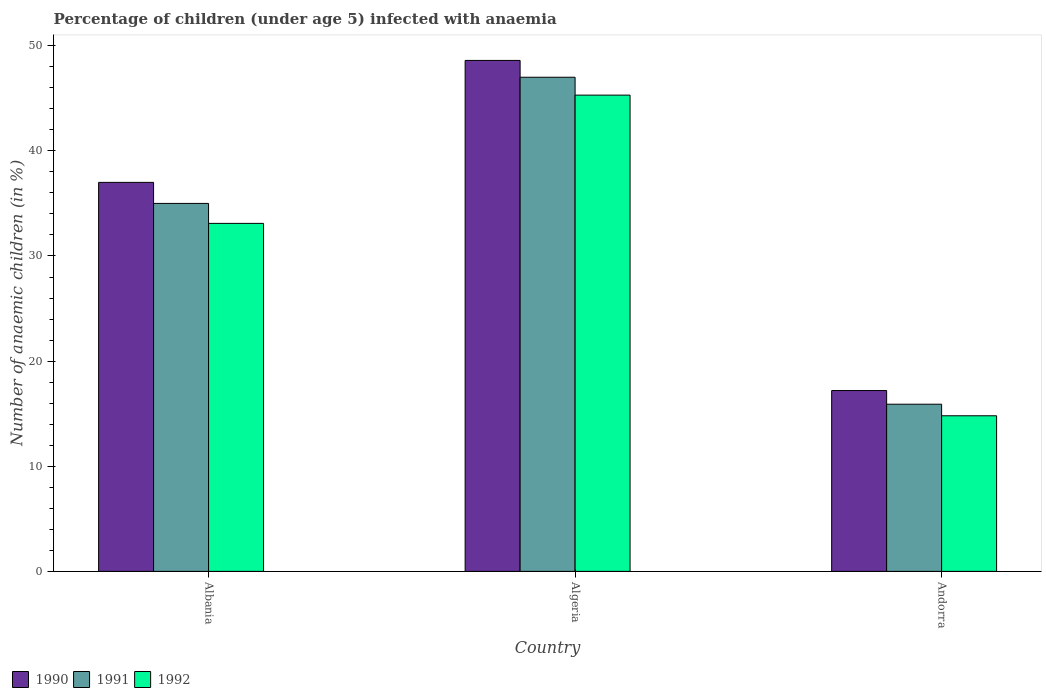Are the number of bars per tick equal to the number of legend labels?
Keep it short and to the point. Yes. How many bars are there on the 2nd tick from the left?
Offer a very short reply. 3. What is the label of the 3rd group of bars from the left?
Your response must be concise. Andorra. What is the percentage of children infected with anaemia in in 1992 in Andorra?
Offer a terse response. 14.8. Across all countries, what is the minimum percentage of children infected with anaemia in in 1992?
Give a very brief answer. 14.8. In which country was the percentage of children infected with anaemia in in 1991 maximum?
Ensure brevity in your answer.  Algeria. In which country was the percentage of children infected with anaemia in in 1990 minimum?
Your answer should be compact. Andorra. What is the total percentage of children infected with anaemia in in 1991 in the graph?
Make the answer very short. 97.9. What is the difference between the percentage of children infected with anaemia in in 1992 in Algeria and that in Andorra?
Provide a short and direct response. 30.5. What is the difference between the percentage of children infected with anaemia in in 1991 in Algeria and the percentage of children infected with anaemia in in 1992 in Albania?
Provide a short and direct response. 13.9. What is the average percentage of children infected with anaemia in in 1991 per country?
Your answer should be very brief. 32.63. What is the difference between the percentage of children infected with anaemia in of/in 1990 and percentage of children infected with anaemia in of/in 1991 in Andorra?
Your answer should be compact. 1.3. In how many countries, is the percentage of children infected with anaemia in in 1990 greater than 10 %?
Your answer should be very brief. 3. What is the ratio of the percentage of children infected with anaemia in in 1991 in Algeria to that in Andorra?
Offer a terse response. 2.96. Is the difference between the percentage of children infected with anaemia in in 1990 in Algeria and Andorra greater than the difference between the percentage of children infected with anaemia in in 1991 in Algeria and Andorra?
Ensure brevity in your answer.  Yes. What is the difference between the highest and the second highest percentage of children infected with anaemia in in 1991?
Keep it short and to the point. 19.1. What is the difference between the highest and the lowest percentage of children infected with anaemia in in 1990?
Keep it short and to the point. 31.4. In how many countries, is the percentage of children infected with anaemia in in 1992 greater than the average percentage of children infected with anaemia in in 1992 taken over all countries?
Provide a succinct answer. 2. Is the sum of the percentage of children infected with anaemia in in 1990 in Albania and Algeria greater than the maximum percentage of children infected with anaemia in in 1992 across all countries?
Ensure brevity in your answer.  Yes. What does the 3rd bar from the left in Albania represents?
Offer a terse response. 1992. How many bars are there?
Make the answer very short. 9. Are all the bars in the graph horizontal?
Your answer should be very brief. No. What is the difference between two consecutive major ticks on the Y-axis?
Make the answer very short. 10. Are the values on the major ticks of Y-axis written in scientific E-notation?
Give a very brief answer. No. Does the graph contain any zero values?
Provide a succinct answer. No. What is the title of the graph?
Provide a short and direct response. Percentage of children (under age 5) infected with anaemia. Does "1974" appear as one of the legend labels in the graph?
Your answer should be very brief. No. What is the label or title of the Y-axis?
Ensure brevity in your answer.  Number of anaemic children (in %). What is the Number of anaemic children (in %) in 1991 in Albania?
Your answer should be very brief. 35. What is the Number of anaemic children (in %) of 1992 in Albania?
Your answer should be compact. 33.1. What is the Number of anaemic children (in %) in 1990 in Algeria?
Your answer should be compact. 48.6. What is the Number of anaemic children (in %) in 1991 in Algeria?
Your answer should be very brief. 47. What is the Number of anaemic children (in %) of 1992 in Algeria?
Provide a succinct answer. 45.3. What is the Number of anaemic children (in %) of 1991 in Andorra?
Your response must be concise. 15.9. What is the Number of anaemic children (in %) in 1992 in Andorra?
Ensure brevity in your answer.  14.8. Across all countries, what is the maximum Number of anaemic children (in %) in 1990?
Give a very brief answer. 48.6. Across all countries, what is the maximum Number of anaemic children (in %) of 1992?
Your response must be concise. 45.3. Across all countries, what is the minimum Number of anaemic children (in %) in 1990?
Give a very brief answer. 17.2. What is the total Number of anaemic children (in %) of 1990 in the graph?
Your answer should be compact. 102.8. What is the total Number of anaemic children (in %) in 1991 in the graph?
Your answer should be very brief. 97.9. What is the total Number of anaemic children (in %) of 1992 in the graph?
Make the answer very short. 93.2. What is the difference between the Number of anaemic children (in %) in 1992 in Albania and that in Algeria?
Give a very brief answer. -12.2. What is the difference between the Number of anaemic children (in %) of 1990 in Albania and that in Andorra?
Make the answer very short. 19.8. What is the difference between the Number of anaemic children (in %) in 1990 in Algeria and that in Andorra?
Give a very brief answer. 31.4. What is the difference between the Number of anaemic children (in %) in 1991 in Algeria and that in Andorra?
Offer a terse response. 31.1. What is the difference between the Number of anaemic children (in %) of 1992 in Algeria and that in Andorra?
Offer a terse response. 30.5. What is the difference between the Number of anaemic children (in %) in 1990 in Albania and the Number of anaemic children (in %) in 1991 in Algeria?
Keep it short and to the point. -10. What is the difference between the Number of anaemic children (in %) in 1990 in Albania and the Number of anaemic children (in %) in 1992 in Algeria?
Ensure brevity in your answer.  -8.3. What is the difference between the Number of anaemic children (in %) in 1990 in Albania and the Number of anaemic children (in %) in 1991 in Andorra?
Your response must be concise. 21.1. What is the difference between the Number of anaemic children (in %) of 1991 in Albania and the Number of anaemic children (in %) of 1992 in Andorra?
Your response must be concise. 20.2. What is the difference between the Number of anaemic children (in %) of 1990 in Algeria and the Number of anaemic children (in %) of 1991 in Andorra?
Your response must be concise. 32.7. What is the difference between the Number of anaemic children (in %) in 1990 in Algeria and the Number of anaemic children (in %) in 1992 in Andorra?
Offer a terse response. 33.8. What is the difference between the Number of anaemic children (in %) in 1991 in Algeria and the Number of anaemic children (in %) in 1992 in Andorra?
Make the answer very short. 32.2. What is the average Number of anaemic children (in %) in 1990 per country?
Your answer should be compact. 34.27. What is the average Number of anaemic children (in %) of 1991 per country?
Your answer should be very brief. 32.63. What is the average Number of anaemic children (in %) in 1992 per country?
Offer a very short reply. 31.07. What is the difference between the Number of anaemic children (in %) of 1990 and Number of anaemic children (in %) of 1991 in Albania?
Give a very brief answer. 2. What is the difference between the Number of anaemic children (in %) in 1990 and Number of anaemic children (in %) in 1992 in Albania?
Keep it short and to the point. 3.9. What is the difference between the Number of anaemic children (in %) in 1991 and Number of anaemic children (in %) in 1992 in Albania?
Your answer should be compact. 1.9. What is the difference between the Number of anaemic children (in %) of 1990 and Number of anaemic children (in %) of 1991 in Andorra?
Make the answer very short. 1.3. What is the ratio of the Number of anaemic children (in %) of 1990 in Albania to that in Algeria?
Give a very brief answer. 0.76. What is the ratio of the Number of anaemic children (in %) of 1991 in Albania to that in Algeria?
Give a very brief answer. 0.74. What is the ratio of the Number of anaemic children (in %) in 1992 in Albania to that in Algeria?
Your response must be concise. 0.73. What is the ratio of the Number of anaemic children (in %) in 1990 in Albania to that in Andorra?
Keep it short and to the point. 2.15. What is the ratio of the Number of anaemic children (in %) of 1991 in Albania to that in Andorra?
Keep it short and to the point. 2.2. What is the ratio of the Number of anaemic children (in %) in 1992 in Albania to that in Andorra?
Offer a terse response. 2.24. What is the ratio of the Number of anaemic children (in %) of 1990 in Algeria to that in Andorra?
Ensure brevity in your answer.  2.83. What is the ratio of the Number of anaemic children (in %) of 1991 in Algeria to that in Andorra?
Your response must be concise. 2.96. What is the ratio of the Number of anaemic children (in %) in 1992 in Algeria to that in Andorra?
Ensure brevity in your answer.  3.06. What is the difference between the highest and the lowest Number of anaemic children (in %) of 1990?
Provide a succinct answer. 31.4. What is the difference between the highest and the lowest Number of anaemic children (in %) of 1991?
Provide a short and direct response. 31.1. What is the difference between the highest and the lowest Number of anaemic children (in %) in 1992?
Make the answer very short. 30.5. 